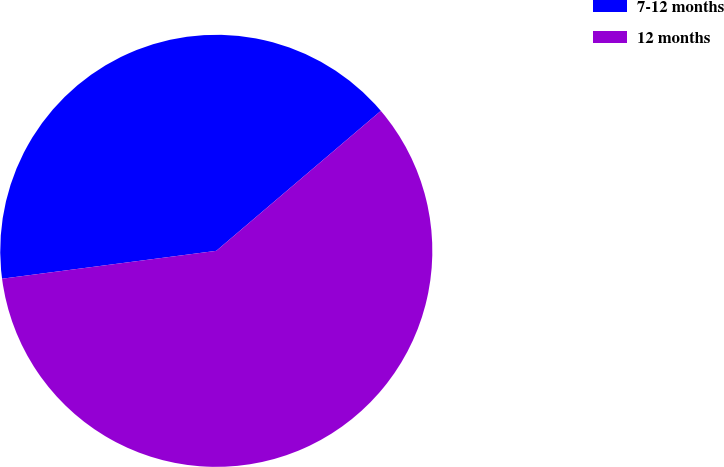<chart> <loc_0><loc_0><loc_500><loc_500><pie_chart><fcel>7-12 months<fcel>12 months<nl><fcel>40.84%<fcel>59.16%<nl></chart> 